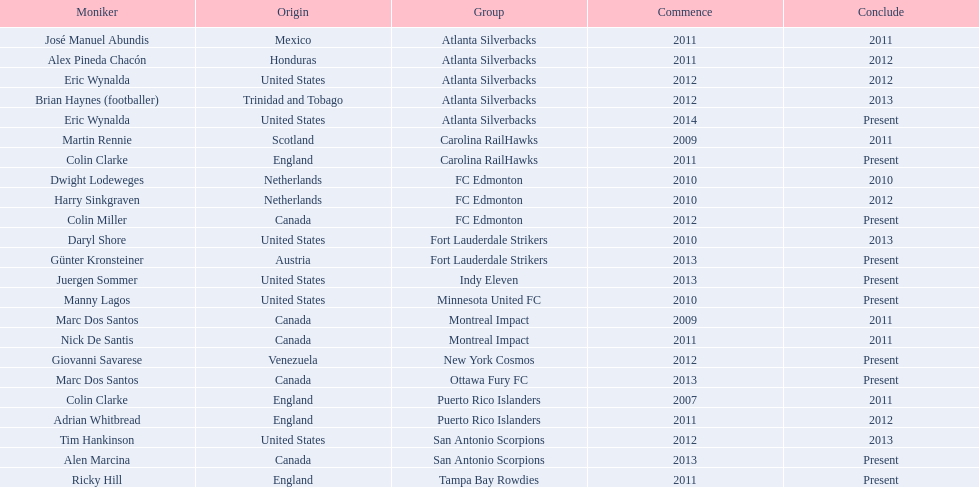How long did colin clarke coach the puerto rico islanders? 4 years. 